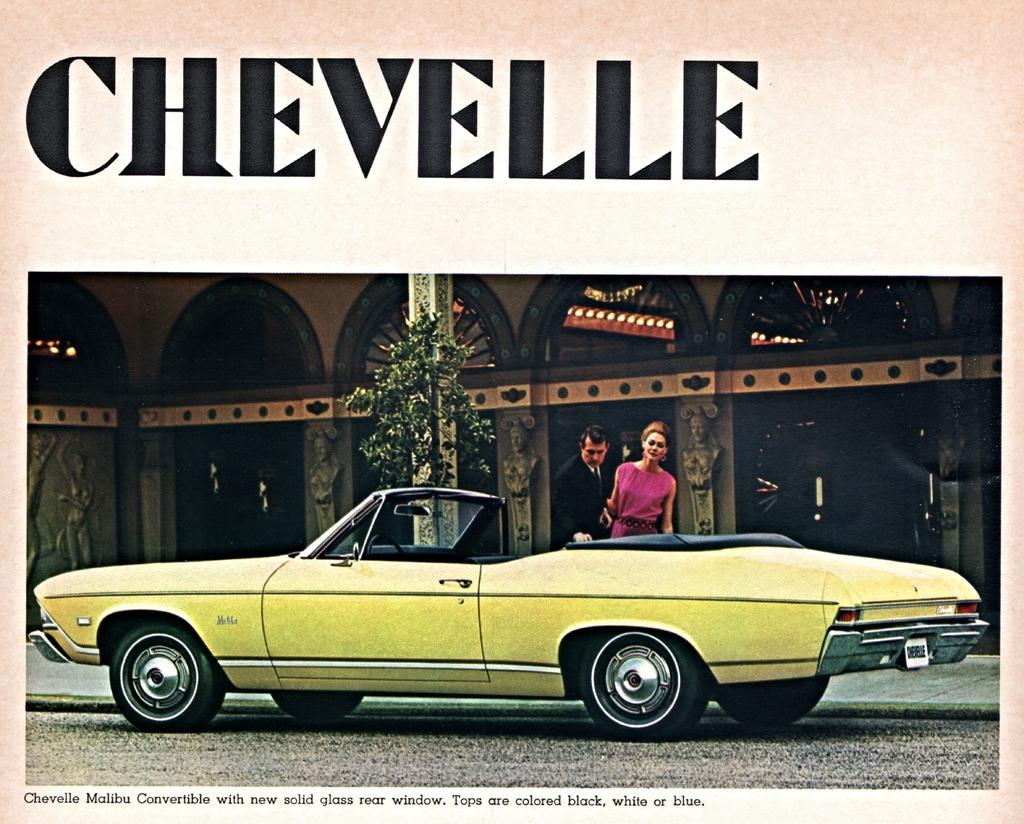How many people are present in the image? There are two people, a man and a woman, present in the image. What are the man and woman doing in the image? Both the man and woman are standing on the road. What else can be seen in the image besides the people? There is a motor vehicle, a plant, and a building in the image. What type of stamp can be seen on the motor vehicle in the image? There is no stamp present on the motor vehicle in the image. What is the weather like in the image, considering the presence of sleet? There is no mention of sleet in the image, so it cannot be determined if the weather is related to sleet. 